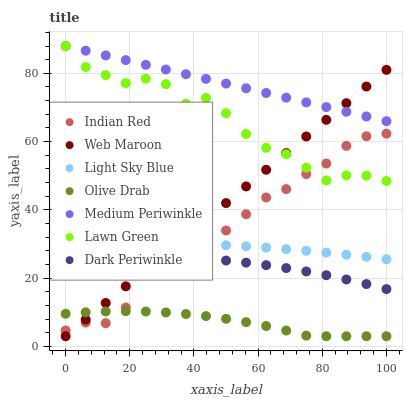Does Olive Drab have the minimum area under the curve?
Answer yes or no. Yes. Does Medium Periwinkle have the maximum area under the curve?
Answer yes or no. Yes. Does Web Maroon have the minimum area under the curve?
Answer yes or no. No. Does Web Maroon have the maximum area under the curve?
Answer yes or no. No. Is Medium Periwinkle the smoothest?
Answer yes or no. Yes. Is Lawn Green the roughest?
Answer yes or no. Yes. Is Web Maroon the smoothest?
Answer yes or no. No. Is Web Maroon the roughest?
Answer yes or no. No. Does Web Maroon have the lowest value?
Answer yes or no. Yes. Does Medium Periwinkle have the lowest value?
Answer yes or no. No. Does Medium Periwinkle have the highest value?
Answer yes or no. Yes. Does Web Maroon have the highest value?
Answer yes or no. No. Is Olive Drab less than Dark Periwinkle?
Answer yes or no. Yes. Is Medium Periwinkle greater than Olive Drab?
Answer yes or no. Yes. Does Indian Red intersect Lawn Green?
Answer yes or no. Yes. Is Indian Red less than Lawn Green?
Answer yes or no. No. Is Indian Red greater than Lawn Green?
Answer yes or no. No. Does Olive Drab intersect Dark Periwinkle?
Answer yes or no. No. 